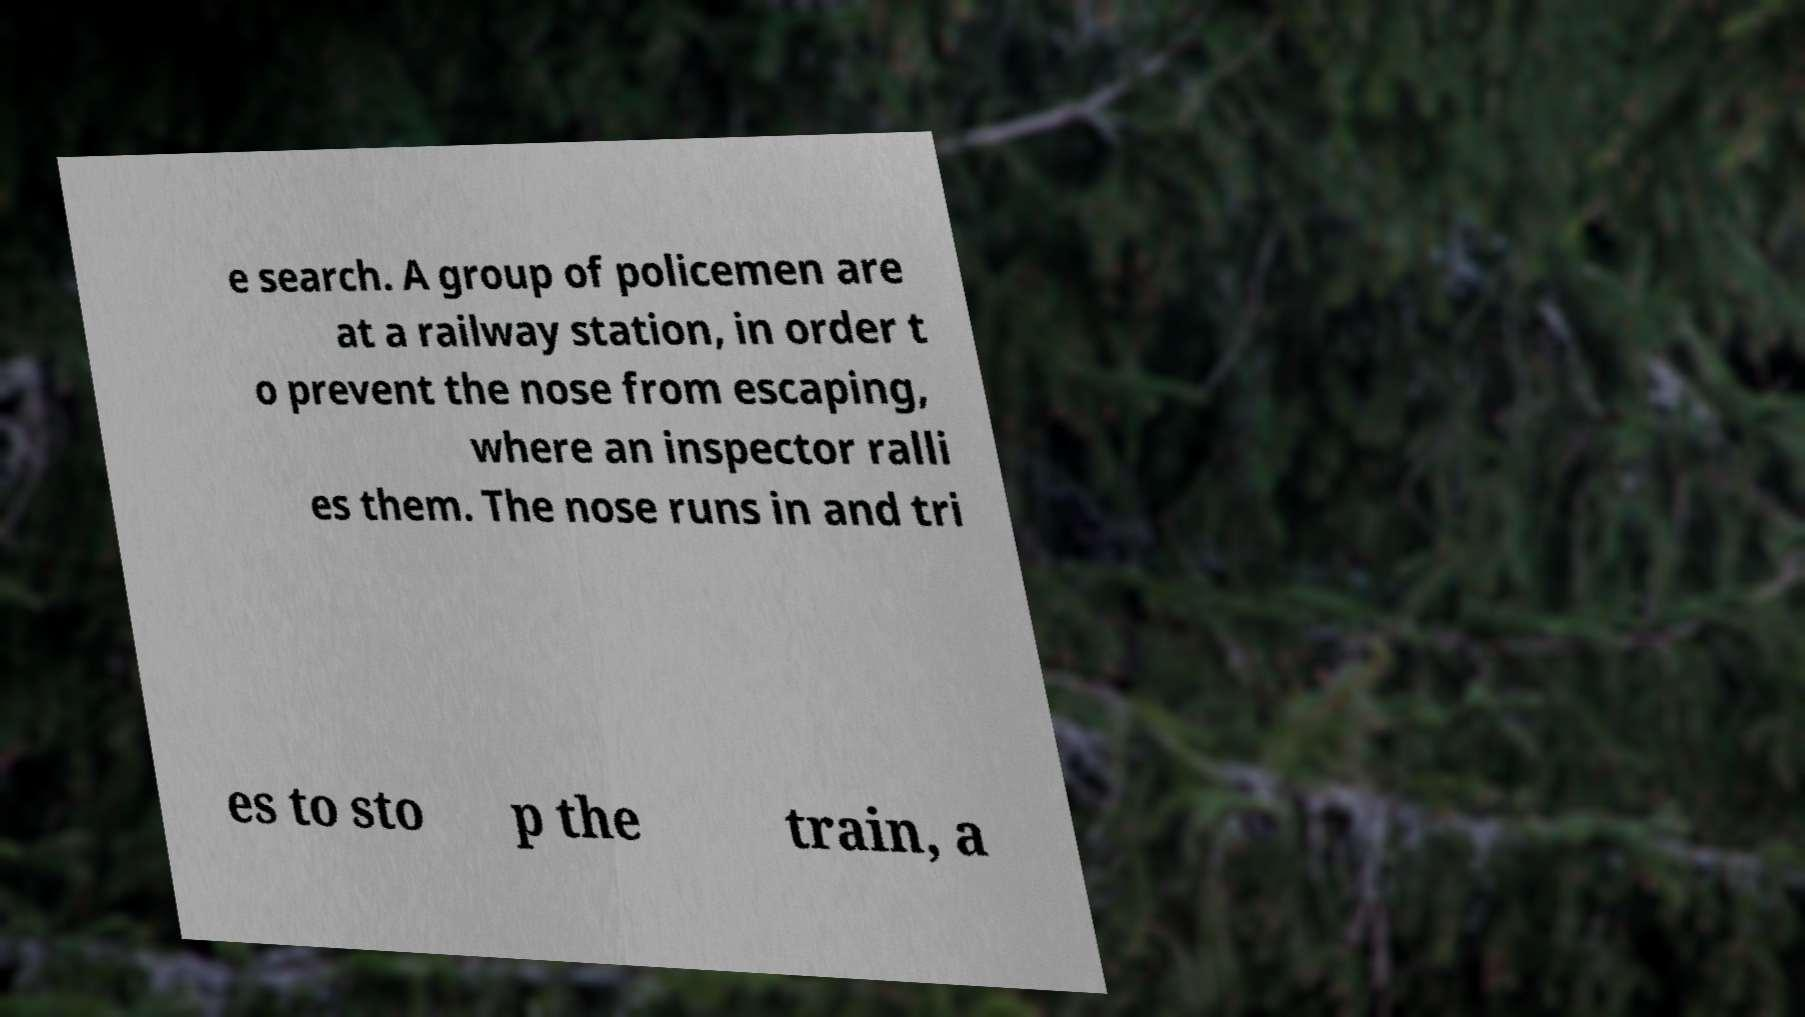For documentation purposes, I need the text within this image transcribed. Could you provide that? e search. A group of policemen are at a railway station, in order t o prevent the nose from escaping, where an inspector ralli es them. The nose runs in and tri es to sto p the train, a 